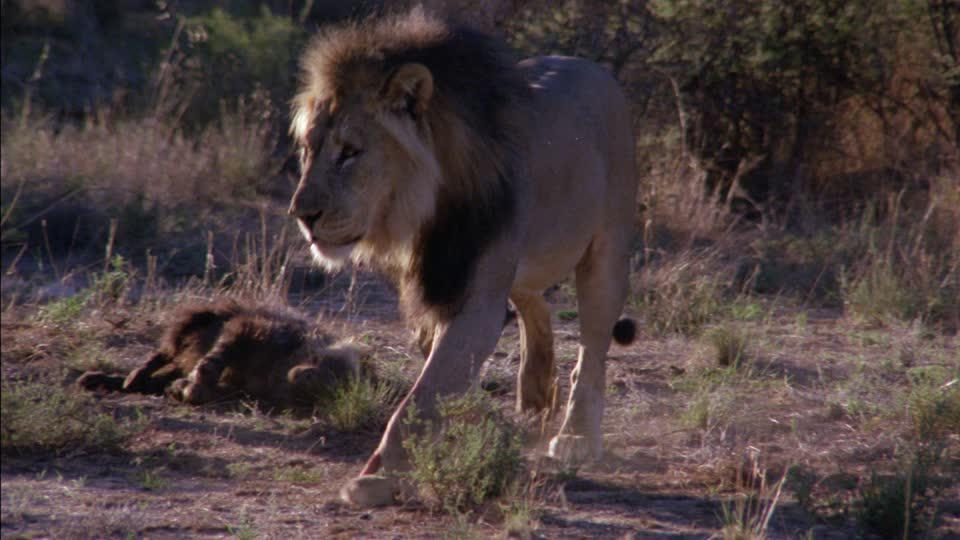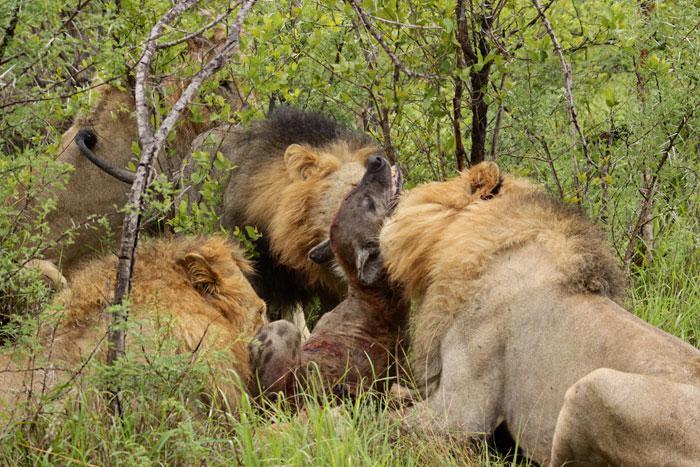The first image is the image on the left, the second image is the image on the right. Analyze the images presented: Is the assertion "In at least one image there is a lion eating a hyena by the neck." valid? Answer yes or no. Yes. The first image is the image on the left, the second image is the image on the right. For the images displayed, is the sentence "The left image contains one lion." factually correct? Answer yes or no. Yes. 